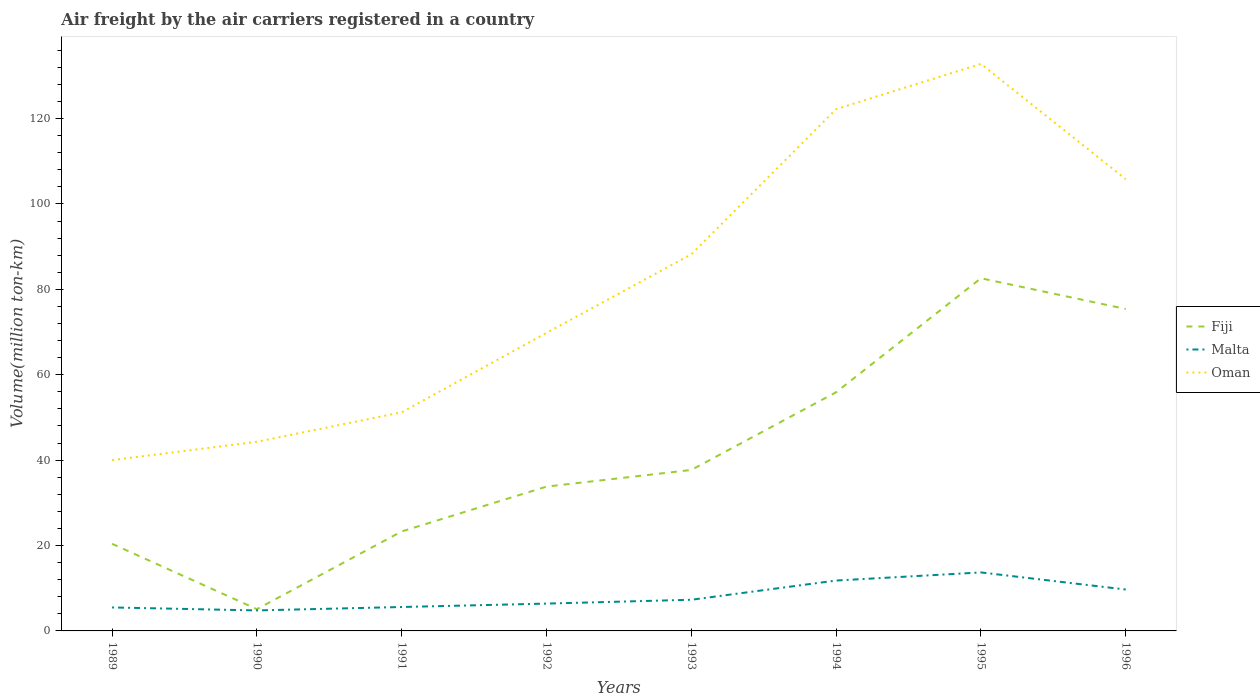How many different coloured lines are there?
Keep it short and to the point. 3. Does the line corresponding to Fiji intersect with the line corresponding to Malta?
Your answer should be compact. No. Is the number of lines equal to the number of legend labels?
Offer a very short reply. Yes. Across all years, what is the maximum volume of the air carriers in Fiji?
Your answer should be very brief. 5.1. In which year was the volume of the air carriers in Malta maximum?
Your response must be concise. 1990. What is the total volume of the air carriers in Fiji in the graph?
Offer a terse response. -18.2. What is the difference between the highest and the second highest volume of the air carriers in Oman?
Make the answer very short. 92.8. Is the volume of the air carriers in Malta strictly greater than the volume of the air carriers in Oman over the years?
Offer a terse response. Yes. How many lines are there?
Offer a very short reply. 3. What is the difference between two consecutive major ticks on the Y-axis?
Keep it short and to the point. 20. Are the values on the major ticks of Y-axis written in scientific E-notation?
Keep it short and to the point. No. Does the graph contain grids?
Keep it short and to the point. No. Where does the legend appear in the graph?
Offer a very short reply. Center right. What is the title of the graph?
Your answer should be compact. Air freight by the air carriers registered in a country. Does "Nicaragua" appear as one of the legend labels in the graph?
Provide a short and direct response. No. What is the label or title of the X-axis?
Offer a terse response. Years. What is the label or title of the Y-axis?
Provide a short and direct response. Volume(million ton-km). What is the Volume(million ton-km) in Fiji in 1989?
Provide a succinct answer. 20.4. What is the Volume(million ton-km) in Malta in 1989?
Make the answer very short. 5.5. What is the Volume(million ton-km) of Oman in 1989?
Give a very brief answer. 40. What is the Volume(million ton-km) of Fiji in 1990?
Your answer should be compact. 5.1. What is the Volume(million ton-km) of Malta in 1990?
Offer a very short reply. 4.8. What is the Volume(million ton-km) in Oman in 1990?
Give a very brief answer. 44.3. What is the Volume(million ton-km) in Fiji in 1991?
Provide a succinct answer. 23.3. What is the Volume(million ton-km) of Malta in 1991?
Your answer should be compact. 5.6. What is the Volume(million ton-km) of Oman in 1991?
Keep it short and to the point. 51.2. What is the Volume(million ton-km) of Fiji in 1992?
Give a very brief answer. 33.8. What is the Volume(million ton-km) of Malta in 1992?
Ensure brevity in your answer.  6.4. What is the Volume(million ton-km) in Oman in 1992?
Your answer should be very brief. 69.8. What is the Volume(million ton-km) of Fiji in 1993?
Offer a terse response. 37.7. What is the Volume(million ton-km) in Malta in 1993?
Offer a very short reply. 7.3. What is the Volume(million ton-km) of Oman in 1993?
Your answer should be compact. 88.2. What is the Volume(million ton-km) of Fiji in 1994?
Ensure brevity in your answer.  55.9. What is the Volume(million ton-km) in Malta in 1994?
Keep it short and to the point. 11.8. What is the Volume(million ton-km) in Oman in 1994?
Ensure brevity in your answer.  122.2. What is the Volume(million ton-km) of Fiji in 1995?
Your response must be concise. 82.6. What is the Volume(million ton-km) of Malta in 1995?
Keep it short and to the point. 13.7. What is the Volume(million ton-km) of Oman in 1995?
Your answer should be very brief. 132.8. What is the Volume(million ton-km) of Fiji in 1996?
Your response must be concise. 75.4. What is the Volume(million ton-km) in Malta in 1996?
Offer a terse response. 9.7. What is the Volume(million ton-km) in Oman in 1996?
Make the answer very short. 105.8. Across all years, what is the maximum Volume(million ton-km) in Fiji?
Offer a very short reply. 82.6. Across all years, what is the maximum Volume(million ton-km) of Malta?
Give a very brief answer. 13.7. Across all years, what is the maximum Volume(million ton-km) of Oman?
Provide a short and direct response. 132.8. Across all years, what is the minimum Volume(million ton-km) in Fiji?
Give a very brief answer. 5.1. Across all years, what is the minimum Volume(million ton-km) of Malta?
Your answer should be compact. 4.8. Across all years, what is the minimum Volume(million ton-km) in Oman?
Your response must be concise. 40. What is the total Volume(million ton-km) in Fiji in the graph?
Your response must be concise. 334.2. What is the total Volume(million ton-km) in Malta in the graph?
Your response must be concise. 64.8. What is the total Volume(million ton-km) in Oman in the graph?
Provide a succinct answer. 654.3. What is the difference between the Volume(million ton-km) in Malta in 1989 and that in 1990?
Offer a very short reply. 0.7. What is the difference between the Volume(million ton-km) of Fiji in 1989 and that in 1991?
Your answer should be compact. -2.9. What is the difference between the Volume(million ton-km) of Malta in 1989 and that in 1991?
Your answer should be compact. -0.1. What is the difference between the Volume(million ton-km) of Oman in 1989 and that in 1991?
Keep it short and to the point. -11.2. What is the difference between the Volume(million ton-km) in Fiji in 1989 and that in 1992?
Your answer should be very brief. -13.4. What is the difference between the Volume(million ton-km) of Malta in 1989 and that in 1992?
Your answer should be very brief. -0.9. What is the difference between the Volume(million ton-km) of Oman in 1989 and that in 1992?
Your answer should be compact. -29.8. What is the difference between the Volume(million ton-km) in Fiji in 1989 and that in 1993?
Provide a short and direct response. -17.3. What is the difference between the Volume(million ton-km) of Malta in 1989 and that in 1993?
Your answer should be compact. -1.8. What is the difference between the Volume(million ton-km) of Oman in 1989 and that in 1993?
Your answer should be compact. -48.2. What is the difference between the Volume(million ton-km) in Fiji in 1989 and that in 1994?
Give a very brief answer. -35.5. What is the difference between the Volume(million ton-km) of Oman in 1989 and that in 1994?
Ensure brevity in your answer.  -82.2. What is the difference between the Volume(million ton-km) of Fiji in 1989 and that in 1995?
Offer a terse response. -62.2. What is the difference between the Volume(million ton-km) in Oman in 1989 and that in 1995?
Provide a short and direct response. -92.8. What is the difference between the Volume(million ton-km) in Fiji in 1989 and that in 1996?
Give a very brief answer. -55. What is the difference between the Volume(million ton-km) of Oman in 1989 and that in 1996?
Make the answer very short. -65.8. What is the difference between the Volume(million ton-km) in Fiji in 1990 and that in 1991?
Your answer should be very brief. -18.2. What is the difference between the Volume(million ton-km) in Fiji in 1990 and that in 1992?
Provide a short and direct response. -28.7. What is the difference between the Volume(million ton-km) of Oman in 1990 and that in 1992?
Give a very brief answer. -25.5. What is the difference between the Volume(million ton-km) of Fiji in 1990 and that in 1993?
Ensure brevity in your answer.  -32.6. What is the difference between the Volume(million ton-km) in Malta in 1990 and that in 1993?
Offer a very short reply. -2.5. What is the difference between the Volume(million ton-km) in Oman in 1990 and that in 1993?
Keep it short and to the point. -43.9. What is the difference between the Volume(million ton-km) in Fiji in 1990 and that in 1994?
Offer a terse response. -50.8. What is the difference between the Volume(million ton-km) of Malta in 1990 and that in 1994?
Keep it short and to the point. -7. What is the difference between the Volume(million ton-km) in Oman in 1990 and that in 1994?
Ensure brevity in your answer.  -77.9. What is the difference between the Volume(million ton-km) of Fiji in 1990 and that in 1995?
Provide a short and direct response. -77.5. What is the difference between the Volume(million ton-km) in Malta in 1990 and that in 1995?
Offer a terse response. -8.9. What is the difference between the Volume(million ton-km) of Oman in 1990 and that in 1995?
Your answer should be very brief. -88.5. What is the difference between the Volume(million ton-km) in Fiji in 1990 and that in 1996?
Give a very brief answer. -70.3. What is the difference between the Volume(million ton-km) of Malta in 1990 and that in 1996?
Your answer should be compact. -4.9. What is the difference between the Volume(million ton-km) of Oman in 1990 and that in 1996?
Make the answer very short. -61.5. What is the difference between the Volume(million ton-km) in Fiji in 1991 and that in 1992?
Offer a very short reply. -10.5. What is the difference between the Volume(million ton-km) in Oman in 1991 and that in 1992?
Ensure brevity in your answer.  -18.6. What is the difference between the Volume(million ton-km) in Fiji in 1991 and that in 1993?
Your response must be concise. -14.4. What is the difference between the Volume(million ton-km) in Malta in 1991 and that in 1993?
Your answer should be compact. -1.7. What is the difference between the Volume(million ton-km) in Oman in 1991 and that in 1993?
Make the answer very short. -37. What is the difference between the Volume(million ton-km) in Fiji in 1991 and that in 1994?
Provide a short and direct response. -32.6. What is the difference between the Volume(million ton-km) of Oman in 1991 and that in 1994?
Offer a terse response. -71. What is the difference between the Volume(million ton-km) of Fiji in 1991 and that in 1995?
Make the answer very short. -59.3. What is the difference between the Volume(million ton-km) in Oman in 1991 and that in 1995?
Ensure brevity in your answer.  -81.6. What is the difference between the Volume(million ton-km) of Fiji in 1991 and that in 1996?
Keep it short and to the point. -52.1. What is the difference between the Volume(million ton-km) of Malta in 1991 and that in 1996?
Make the answer very short. -4.1. What is the difference between the Volume(million ton-km) in Oman in 1991 and that in 1996?
Provide a succinct answer. -54.6. What is the difference between the Volume(million ton-km) of Oman in 1992 and that in 1993?
Keep it short and to the point. -18.4. What is the difference between the Volume(million ton-km) of Fiji in 1992 and that in 1994?
Ensure brevity in your answer.  -22.1. What is the difference between the Volume(million ton-km) of Oman in 1992 and that in 1994?
Ensure brevity in your answer.  -52.4. What is the difference between the Volume(million ton-km) of Fiji in 1992 and that in 1995?
Keep it short and to the point. -48.8. What is the difference between the Volume(million ton-km) in Oman in 1992 and that in 1995?
Your answer should be very brief. -63. What is the difference between the Volume(million ton-km) of Fiji in 1992 and that in 1996?
Provide a short and direct response. -41.6. What is the difference between the Volume(million ton-km) of Oman in 1992 and that in 1996?
Ensure brevity in your answer.  -36. What is the difference between the Volume(million ton-km) of Fiji in 1993 and that in 1994?
Make the answer very short. -18.2. What is the difference between the Volume(million ton-km) in Oman in 1993 and that in 1994?
Make the answer very short. -34. What is the difference between the Volume(million ton-km) of Fiji in 1993 and that in 1995?
Provide a succinct answer. -44.9. What is the difference between the Volume(million ton-km) of Oman in 1993 and that in 1995?
Your answer should be compact. -44.6. What is the difference between the Volume(million ton-km) of Fiji in 1993 and that in 1996?
Ensure brevity in your answer.  -37.7. What is the difference between the Volume(million ton-km) in Malta in 1993 and that in 1996?
Make the answer very short. -2.4. What is the difference between the Volume(million ton-km) in Oman in 1993 and that in 1996?
Ensure brevity in your answer.  -17.6. What is the difference between the Volume(million ton-km) in Fiji in 1994 and that in 1995?
Make the answer very short. -26.7. What is the difference between the Volume(million ton-km) in Malta in 1994 and that in 1995?
Offer a terse response. -1.9. What is the difference between the Volume(million ton-km) in Oman in 1994 and that in 1995?
Keep it short and to the point. -10.6. What is the difference between the Volume(million ton-km) of Fiji in 1994 and that in 1996?
Provide a succinct answer. -19.5. What is the difference between the Volume(million ton-km) of Malta in 1994 and that in 1996?
Offer a very short reply. 2.1. What is the difference between the Volume(million ton-km) in Fiji in 1995 and that in 1996?
Provide a succinct answer. 7.2. What is the difference between the Volume(million ton-km) in Malta in 1995 and that in 1996?
Your answer should be very brief. 4. What is the difference between the Volume(million ton-km) of Fiji in 1989 and the Volume(million ton-km) of Malta in 1990?
Offer a very short reply. 15.6. What is the difference between the Volume(million ton-km) of Fiji in 1989 and the Volume(million ton-km) of Oman in 1990?
Give a very brief answer. -23.9. What is the difference between the Volume(million ton-km) of Malta in 1989 and the Volume(million ton-km) of Oman in 1990?
Ensure brevity in your answer.  -38.8. What is the difference between the Volume(million ton-km) in Fiji in 1989 and the Volume(million ton-km) in Oman in 1991?
Ensure brevity in your answer.  -30.8. What is the difference between the Volume(million ton-km) in Malta in 1989 and the Volume(million ton-km) in Oman in 1991?
Offer a very short reply. -45.7. What is the difference between the Volume(million ton-km) in Fiji in 1989 and the Volume(million ton-km) in Oman in 1992?
Offer a terse response. -49.4. What is the difference between the Volume(million ton-km) of Malta in 1989 and the Volume(million ton-km) of Oman in 1992?
Your answer should be compact. -64.3. What is the difference between the Volume(million ton-km) in Fiji in 1989 and the Volume(million ton-km) in Oman in 1993?
Ensure brevity in your answer.  -67.8. What is the difference between the Volume(million ton-km) of Malta in 1989 and the Volume(million ton-km) of Oman in 1993?
Your response must be concise. -82.7. What is the difference between the Volume(million ton-km) of Fiji in 1989 and the Volume(million ton-km) of Oman in 1994?
Offer a terse response. -101.8. What is the difference between the Volume(million ton-km) of Malta in 1989 and the Volume(million ton-km) of Oman in 1994?
Keep it short and to the point. -116.7. What is the difference between the Volume(million ton-km) of Fiji in 1989 and the Volume(million ton-km) of Oman in 1995?
Offer a terse response. -112.4. What is the difference between the Volume(million ton-km) in Malta in 1989 and the Volume(million ton-km) in Oman in 1995?
Offer a terse response. -127.3. What is the difference between the Volume(million ton-km) in Fiji in 1989 and the Volume(million ton-km) in Oman in 1996?
Your answer should be compact. -85.4. What is the difference between the Volume(million ton-km) of Malta in 1989 and the Volume(million ton-km) of Oman in 1996?
Provide a short and direct response. -100.3. What is the difference between the Volume(million ton-km) of Fiji in 1990 and the Volume(million ton-km) of Oman in 1991?
Provide a short and direct response. -46.1. What is the difference between the Volume(million ton-km) in Malta in 1990 and the Volume(million ton-km) in Oman in 1991?
Your response must be concise. -46.4. What is the difference between the Volume(million ton-km) of Fiji in 1990 and the Volume(million ton-km) of Malta in 1992?
Give a very brief answer. -1.3. What is the difference between the Volume(million ton-km) in Fiji in 1990 and the Volume(million ton-km) in Oman in 1992?
Provide a short and direct response. -64.7. What is the difference between the Volume(million ton-km) in Malta in 1990 and the Volume(million ton-km) in Oman in 1992?
Your answer should be compact. -65. What is the difference between the Volume(million ton-km) of Fiji in 1990 and the Volume(million ton-km) of Oman in 1993?
Make the answer very short. -83.1. What is the difference between the Volume(million ton-km) in Malta in 1990 and the Volume(million ton-km) in Oman in 1993?
Give a very brief answer. -83.4. What is the difference between the Volume(million ton-km) of Fiji in 1990 and the Volume(million ton-km) of Oman in 1994?
Give a very brief answer. -117.1. What is the difference between the Volume(million ton-km) of Malta in 1990 and the Volume(million ton-km) of Oman in 1994?
Your answer should be very brief. -117.4. What is the difference between the Volume(million ton-km) in Fiji in 1990 and the Volume(million ton-km) in Malta in 1995?
Provide a succinct answer. -8.6. What is the difference between the Volume(million ton-km) in Fiji in 1990 and the Volume(million ton-km) in Oman in 1995?
Provide a short and direct response. -127.7. What is the difference between the Volume(million ton-km) in Malta in 1990 and the Volume(million ton-km) in Oman in 1995?
Offer a terse response. -128. What is the difference between the Volume(million ton-km) of Fiji in 1990 and the Volume(million ton-km) of Malta in 1996?
Ensure brevity in your answer.  -4.6. What is the difference between the Volume(million ton-km) in Fiji in 1990 and the Volume(million ton-km) in Oman in 1996?
Provide a short and direct response. -100.7. What is the difference between the Volume(million ton-km) of Malta in 1990 and the Volume(million ton-km) of Oman in 1996?
Make the answer very short. -101. What is the difference between the Volume(million ton-km) of Fiji in 1991 and the Volume(million ton-km) of Malta in 1992?
Your answer should be very brief. 16.9. What is the difference between the Volume(million ton-km) in Fiji in 1991 and the Volume(million ton-km) in Oman in 1992?
Give a very brief answer. -46.5. What is the difference between the Volume(million ton-km) in Malta in 1991 and the Volume(million ton-km) in Oman in 1992?
Ensure brevity in your answer.  -64.2. What is the difference between the Volume(million ton-km) in Fiji in 1991 and the Volume(million ton-km) in Oman in 1993?
Keep it short and to the point. -64.9. What is the difference between the Volume(million ton-km) in Malta in 1991 and the Volume(million ton-km) in Oman in 1993?
Your response must be concise. -82.6. What is the difference between the Volume(million ton-km) of Fiji in 1991 and the Volume(million ton-km) of Malta in 1994?
Offer a very short reply. 11.5. What is the difference between the Volume(million ton-km) in Fiji in 1991 and the Volume(million ton-km) in Oman in 1994?
Provide a short and direct response. -98.9. What is the difference between the Volume(million ton-km) of Malta in 1991 and the Volume(million ton-km) of Oman in 1994?
Ensure brevity in your answer.  -116.6. What is the difference between the Volume(million ton-km) in Fiji in 1991 and the Volume(million ton-km) in Malta in 1995?
Offer a very short reply. 9.6. What is the difference between the Volume(million ton-km) in Fiji in 1991 and the Volume(million ton-km) in Oman in 1995?
Ensure brevity in your answer.  -109.5. What is the difference between the Volume(million ton-km) of Malta in 1991 and the Volume(million ton-km) of Oman in 1995?
Provide a succinct answer. -127.2. What is the difference between the Volume(million ton-km) in Fiji in 1991 and the Volume(million ton-km) in Oman in 1996?
Your response must be concise. -82.5. What is the difference between the Volume(million ton-km) of Malta in 1991 and the Volume(million ton-km) of Oman in 1996?
Your response must be concise. -100.2. What is the difference between the Volume(million ton-km) in Fiji in 1992 and the Volume(million ton-km) in Malta in 1993?
Offer a very short reply. 26.5. What is the difference between the Volume(million ton-km) in Fiji in 1992 and the Volume(million ton-km) in Oman in 1993?
Your answer should be very brief. -54.4. What is the difference between the Volume(million ton-km) of Malta in 1992 and the Volume(million ton-km) of Oman in 1993?
Ensure brevity in your answer.  -81.8. What is the difference between the Volume(million ton-km) in Fiji in 1992 and the Volume(million ton-km) in Oman in 1994?
Your answer should be very brief. -88.4. What is the difference between the Volume(million ton-km) in Malta in 1992 and the Volume(million ton-km) in Oman in 1994?
Provide a short and direct response. -115.8. What is the difference between the Volume(million ton-km) in Fiji in 1992 and the Volume(million ton-km) in Malta in 1995?
Provide a short and direct response. 20.1. What is the difference between the Volume(million ton-km) in Fiji in 1992 and the Volume(million ton-km) in Oman in 1995?
Keep it short and to the point. -99. What is the difference between the Volume(million ton-km) of Malta in 1992 and the Volume(million ton-km) of Oman in 1995?
Your answer should be very brief. -126.4. What is the difference between the Volume(million ton-km) of Fiji in 1992 and the Volume(million ton-km) of Malta in 1996?
Ensure brevity in your answer.  24.1. What is the difference between the Volume(million ton-km) of Fiji in 1992 and the Volume(million ton-km) of Oman in 1996?
Your answer should be very brief. -72. What is the difference between the Volume(million ton-km) in Malta in 1992 and the Volume(million ton-km) in Oman in 1996?
Your response must be concise. -99.4. What is the difference between the Volume(million ton-km) of Fiji in 1993 and the Volume(million ton-km) of Malta in 1994?
Ensure brevity in your answer.  25.9. What is the difference between the Volume(million ton-km) of Fiji in 1993 and the Volume(million ton-km) of Oman in 1994?
Provide a short and direct response. -84.5. What is the difference between the Volume(million ton-km) of Malta in 1993 and the Volume(million ton-km) of Oman in 1994?
Your answer should be compact. -114.9. What is the difference between the Volume(million ton-km) in Fiji in 1993 and the Volume(million ton-km) in Oman in 1995?
Offer a terse response. -95.1. What is the difference between the Volume(million ton-km) of Malta in 1993 and the Volume(million ton-km) of Oman in 1995?
Offer a terse response. -125.5. What is the difference between the Volume(million ton-km) in Fiji in 1993 and the Volume(million ton-km) in Malta in 1996?
Give a very brief answer. 28. What is the difference between the Volume(million ton-km) of Fiji in 1993 and the Volume(million ton-km) of Oman in 1996?
Ensure brevity in your answer.  -68.1. What is the difference between the Volume(million ton-km) in Malta in 1993 and the Volume(million ton-km) in Oman in 1996?
Provide a short and direct response. -98.5. What is the difference between the Volume(million ton-km) in Fiji in 1994 and the Volume(million ton-km) in Malta in 1995?
Provide a succinct answer. 42.2. What is the difference between the Volume(million ton-km) of Fiji in 1994 and the Volume(million ton-km) of Oman in 1995?
Provide a short and direct response. -76.9. What is the difference between the Volume(million ton-km) in Malta in 1994 and the Volume(million ton-km) in Oman in 1995?
Ensure brevity in your answer.  -121. What is the difference between the Volume(million ton-km) in Fiji in 1994 and the Volume(million ton-km) in Malta in 1996?
Keep it short and to the point. 46.2. What is the difference between the Volume(million ton-km) in Fiji in 1994 and the Volume(million ton-km) in Oman in 1996?
Offer a terse response. -49.9. What is the difference between the Volume(million ton-km) in Malta in 1994 and the Volume(million ton-km) in Oman in 1996?
Your answer should be compact. -94. What is the difference between the Volume(million ton-km) of Fiji in 1995 and the Volume(million ton-km) of Malta in 1996?
Ensure brevity in your answer.  72.9. What is the difference between the Volume(million ton-km) of Fiji in 1995 and the Volume(million ton-km) of Oman in 1996?
Make the answer very short. -23.2. What is the difference between the Volume(million ton-km) in Malta in 1995 and the Volume(million ton-km) in Oman in 1996?
Make the answer very short. -92.1. What is the average Volume(million ton-km) of Fiji per year?
Provide a succinct answer. 41.77. What is the average Volume(million ton-km) in Oman per year?
Your answer should be compact. 81.79. In the year 1989, what is the difference between the Volume(million ton-km) of Fiji and Volume(million ton-km) of Oman?
Give a very brief answer. -19.6. In the year 1989, what is the difference between the Volume(million ton-km) of Malta and Volume(million ton-km) of Oman?
Provide a succinct answer. -34.5. In the year 1990, what is the difference between the Volume(million ton-km) in Fiji and Volume(million ton-km) in Malta?
Ensure brevity in your answer.  0.3. In the year 1990, what is the difference between the Volume(million ton-km) in Fiji and Volume(million ton-km) in Oman?
Your answer should be very brief. -39.2. In the year 1990, what is the difference between the Volume(million ton-km) in Malta and Volume(million ton-km) in Oman?
Provide a succinct answer. -39.5. In the year 1991, what is the difference between the Volume(million ton-km) of Fiji and Volume(million ton-km) of Malta?
Your answer should be compact. 17.7. In the year 1991, what is the difference between the Volume(million ton-km) in Fiji and Volume(million ton-km) in Oman?
Your response must be concise. -27.9. In the year 1991, what is the difference between the Volume(million ton-km) of Malta and Volume(million ton-km) of Oman?
Give a very brief answer. -45.6. In the year 1992, what is the difference between the Volume(million ton-km) in Fiji and Volume(million ton-km) in Malta?
Keep it short and to the point. 27.4. In the year 1992, what is the difference between the Volume(million ton-km) of Fiji and Volume(million ton-km) of Oman?
Keep it short and to the point. -36. In the year 1992, what is the difference between the Volume(million ton-km) of Malta and Volume(million ton-km) of Oman?
Offer a very short reply. -63.4. In the year 1993, what is the difference between the Volume(million ton-km) in Fiji and Volume(million ton-km) in Malta?
Keep it short and to the point. 30.4. In the year 1993, what is the difference between the Volume(million ton-km) in Fiji and Volume(million ton-km) in Oman?
Give a very brief answer. -50.5. In the year 1993, what is the difference between the Volume(million ton-km) in Malta and Volume(million ton-km) in Oman?
Your response must be concise. -80.9. In the year 1994, what is the difference between the Volume(million ton-km) of Fiji and Volume(million ton-km) of Malta?
Offer a very short reply. 44.1. In the year 1994, what is the difference between the Volume(million ton-km) in Fiji and Volume(million ton-km) in Oman?
Ensure brevity in your answer.  -66.3. In the year 1994, what is the difference between the Volume(million ton-km) of Malta and Volume(million ton-km) of Oman?
Make the answer very short. -110.4. In the year 1995, what is the difference between the Volume(million ton-km) of Fiji and Volume(million ton-km) of Malta?
Keep it short and to the point. 68.9. In the year 1995, what is the difference between the Volume(million ton-km) of Fiji and Volume(million ton-km) of Oman?
Your answer should be compact. -50.2. In the year 1995, what is the difference between the Volume(million ton-km) of Malta and Volume(million ton-km) of Oman?
Make the answer very short. -119.1. In the year 1996, what is the difference between the Volume(million ton-km) in Fiji and Volume(million ton-km) in Malta?
Give a very brief answer. 65.7. In the year 1996, what is the difference between the Volume(million ton-km) of Fiji and Volume(million ton-km) of Oman?
Ensure brevity in your answer.  -30.4. In the year 1996, what is the difference between the Volume(million ton-km) in Malta and Volume(million ton-km) in Oman?
Your answer should be very brief. -96.1. What is the ratio of the Volume(million ton-km) of Fiji in 1989 to that in 1990?
Keep it short and to the point. 4. What is the ratio of the Volume(million ton-km) in Malta in 1989 to that in 1990?
Make the answer very short. 1.15. What is the ratio of the Volume(million ton-km) of Oman in 1989 to that in 1990?
Offer a terse response. 0.9. What is the ratio of the Volume(million ton-km) in Fiji in 1989 to that in 1991?
Offer a terse response. 0.88. What is the ratio of the Volume(million ton-km) of Malta in 1989 to that in 1991?
Make the answer very short. 0.98. What is the ratio of the Volume(million ton-km) in Oman in 1989 to that in 1991?
Make the answer very short. 0.78. What is the ratio of the Volume(million ton-km) in Fiji in 1989 to that in 1992?
Ensure brevity in your answer.  0.6. What is the ratio of the Volume(million ton-km) in Malta in 1989 to that in 1992?
Give a very brief answer. 0.86. What is the ratio of the Volume(million ton-km) of Oman in 1989 to that in 1992?
Give a very brief answer. 0.57. What is the ratio of the Volume(million ton-km) in Fiji in 1989 to that in 1993?
Ensure brevity in your answer.  0.54. What is the ratio of the Volume(million ton-km) in Malta in 1989 to that in 1993?
Your response must be concise. 0.75. What is the ratio of the Volume(million ton-km) of Oman in 1989 to that in 1993?
Give a very brief answer. 0.45. What is the ratio of the Volume(million ton-km) in Fiji in 1989 to that in 1994?
Your answer should be compact. 0.36. What is the ratio of the Volume(million ton-km) in Malta in 1989 to that in 1994?
Offer a very short reply. 0.47. What is the ratio of the Volume(million ton-km) of Oman in 1989 to that in 1994?
Your answer should be very brief. 0.33. What is the ratio of the Volume(million ton-km) of Fiji in 1989 to that in 1995?
Make the answer very short. 0.25. What is the ratio of the Volume(million ton-km) in Malta in 1989 to that in 1995?
Give a very brief answer. 0.4. What is the ratio of the Volume(million ton-km) in Oman in 1989 to that in 1995?
Your response must be concise. 0.3. What is the ratio of the Volume(million ton-km) of Fiji in 1989 to that in 1996?
Your answer should be compact. 0.27. What is the ratio of the Volume(million ton-km) of Malta in 1989 to that in 1996?
Make the answer very short. 0.57. What is the ratio of the Volume(million ton-km) of Oman in 1989 to that in 1996?
Keep it short and to the point. 0.38. What is the ratio of the Volume(million ton-km) of Fiji in 1990 to that in 1991?
Keep it short and to the point. 0.22. What is the ratio of the Volume(million ton-km) in Oman in 1990 to that in 1991?
Give a very brief answer. 0.87. What is the ratio of the Volume(million ton-km) of Fiji in 1990 to that in 1992?
Ensure brevity in your answer.  0.15. What is the ratio of the Volume(million ton-km) in Malta in 1990 to that in 1992?
Offer a terse response. 0.75. What is the ratio of the Volume(million ton-km) in Oman in 1990 to that in 1992?
Keep it short and to the point. 0.63. What is the ratio of the Volume(million ton-km) in Fiji in 1990 to that in 1993?
Provide a succinct answer. 0.14. What is the ratio of the Volume(million ton-km) in Malta in 1990 to that in 1993?
Offer a very short reply. 0.66. What is the ratio of the Volume(million ton-km) in Oman in 1990 to that in 1993?
Your response must be concise. 0.5. What is the ratio of the Volume(million ton-km) in Fiji in 1990 to that in 1994?
Offer a very short reply. 0.09. What is the ratio of the Volume(million ton-km) of Malta in 1990 to that in 1994?
Your answer should be compact. 0.41. What is the ratio of the Volume(million ton-km) in Oman in 1990 to that in 1994?
Your answer should be very brief. 0.36. What is the ratio of the Volume(million ton-km) of Fiji in 1990 to that in 1995?
Give a very brief answer. 0.06. What is the ratio of the Volume(million ton-km) of Malta in 1990 to that in 1995?
Your answer should be very brief. 0.35. What is the ratio of the Volume(million ton-km) in Oman in 1990 to that in 1995?
Your answer should be compact. 0.33. What is the ratio of the Volume(million ton-km) of Fiji in 1990 to that in 1996?
Offer a very short reply. 0.07. What is the ratio of the Volume(million ton-km) of Malta in 1990 to that in 1996?
Your response must be concise. 0.49. What is the ratio of the Volume(million ton-km) of Oman in 1990 to that in 1996?
Your answer should be very brief. 0.42. What is the ratio of the Volume(million ton-km) in Fiji in 1991 to that in 1992?
Make the answer very short. 0.69. What is the ratio of the Volume(million ton-km) of Malta in 1991 to that in 1992?
Your answer should be compact. 0.88. What is the ratio of the Volume(million ton-km) of Oman in 1991 to that in 1992?
Your answer should be compact. 0.73. What is the ratio of the Volume(million ton-km) in Fiji in 1991 to that in 1993?
Provide a succinct answer. 0.62. What is the ratio of the Volume(million ton-km) in Malta in 1991 to that in 1993?
Your answer should be very brief. 0.77. What is the ratio of the Volume(million ton-km) of Oman in 1991 to that in 1993?
Provide a short and direct response. 0.58. What is the ratio of the Volume(million ton-km) in Fiji in 1991 to that in 1994?
Ensure brevity in your answer.  0.42. What is the ratio of the Volume(million ton-km) in Malta in 1991 to that in 1994?
Keep it short and to the point. 0.47. What is the ratio of the Volume(million ton-km) in Oman in 1991 to that in 1994?
Provide a succinct answer. 0.42. What is the ratio of the Volume(million ton-km) in Fiji in 1991 to that in 1995?
Offer a terse response. 0.28. What is the ratio of the Volume(million ton-km) of Malta in 1991 to that in 1995?
Offer a terse response. 0.41. What is the ratio of the Volume(million ton-km) in Oman in 1991 to that in 1995?
Offer a terse response. 0.39. What is the ratio of the Volume(million ton-km) of Fiji in 1991 to that in 1996?
Your response must be concise. 0.31. What is the ratio of the Volume(million ton-km) in Malta in 1991 to that in 1996?
Provide a short and direct response. 0.58. What is the ratio of the Volume(million ton-km) in Oman in 1991 to that in 1996?
Your answer should be very brief. 0.48. What is the ratio of the Volume(million ton-km) in Fiji in 1992 to that in 1993?
Your answer should be very brief. 0.9. What is the ratio of the Volume(million ton-km) of Malta in 1992 to that in 1993?
Make the answer very short. 0.88. What is the ratio of the Volume(million ton-km) in Oman in 1992 to that in 1993?
Your answer should be very brief. 0.79. What is the ratio of the Volume(million ton-km) in Fiji in 1992 to that in 1994?
Offer a very short reply. 0.6. What is the ratio of the Volume(million ton-km) in Malta in 1992 to that in 1994?
Your answer should be compact. 0.54. What is the ratio of the Volume(million ton-km) in Oman in 1992 to that in 1994?
Make the answer very short. 0.57. What is the ratio of the Volume(million ton-km) of Fiji in 1992 to that in 1995?
Your answer should be very brief. 0.41. What is the ratio of the Volume(million ton-km) of Malta in 1992 to that in 1995?
Provide a short and direct response. 0.47. What is the ratio of the Volume(million ton-km) in Oman in 1992 to that in 1995?
Keep it short and to the point. 0.53. What is the ratio of the Volume(million ton-km) of Fiji in 1992 to that in 1996?
Your answer should be compact. 0.45. What is the ratio of the Volume(million ton-km) in Malta in 1992 to that in 1996?
Your response must be concise. 0.66. What is the ratio of the Volume(million ton-km) in Oman in 1992 to that in 1996?
Give a very brief answer. 0.66. What is the ratio of the Volume(million ton-km) in Fiji in 1993 to that in 1994?
Your response must be concise. 0.67. What is the ratio of the Volume(million ton-km) in Malta in 1993 to that in 1994?
Your answer should be compact. 0.62. What is the ratio of the Volume(million ton-km) of Oman in 1993 to that in 1994?
Give a very brief answer. 0.72. What is the ratio of the Volume(million ton-km) of Fiji in 1993 to that in 1995?
Your response must be concise. 0.46. What is the ratio of the Volume(million ton-km) of Malta in 1993 to that in 1995?
Offer a terse response. 0.53. What is the ratio of the Volume(million ton-km) of Oman in 1993 to that in 1995?
Give a very brief answer. 0.66. What is the ratio of the Volume(million ton-km) in Malta in 1993 to that in 1996?
Provide a short and direct response. 0.75. What is the ratio of the Volume(million ton-km) of Oman in 1993 to that in 1996?
Offer a very short reply. 0.83. What is the ratio of the Volume(million ton-km) of Fiji in 1994 to that in 1995?
Make the answer very short. 0.68. What is the ratio of the Volume(million ton-km) of Malta in 1994 to that in 1995?
Offer a very short reply. 0.86. What is the ratio of the Volume(million ton-km) in Oman in 1994 to that in 1995?
Your answer should be very brief. 0.92. What is the ratio of the Volume(million ton-km) of Fiji in 1994 to that in 1996?
Keep it short and to the point. 0.74. What is the ratio of the Volume(million ton-km) of Malta in 1994 to that in 1996?
Make the answer very short. 1.22. What is the ratio of the Volume(million ton-km) of Oman in 1994 to that in 1996?
Make the answer very short. 1.16. What is the ratio of the Volume(million ton-km) of Fiji in 1995 to that in 1996?
Your answer should be compact. 1.1. What is the ratio of the Volume(million ton-km) in Malta in 1995 to that in 1996?
Offer a terse response. 1.41. What is the ratio of the Volume(million ton-km) in Oman in 1995 to that in 1996?
Keep it short and to the point. 1.26. What is the difference between the highest and the second highest Volume(million ton-km) in Fiji?
Provide a succinct answer. 7.2. What is the difference between the highest and the second highest Volume(million ton-km) in Malta?
Your answer should be compact. 1.9. What is the difference between the highest and the second highest Volume(million ton-km) of Oman?
Your response must be concise. 10.6. What is the difference between the highest and the lowest Volume(million ton-km) of Fiji?
Your answer should be very brief. 77.5. What is the difference between the highest and the lowest Volume(million ton-km) of Malta?
Your response must be concise. 8.9. What is the difference between the highest and the lowest Volume(million ton-km) of Oman?
Offer a very short reply. 92.8. 